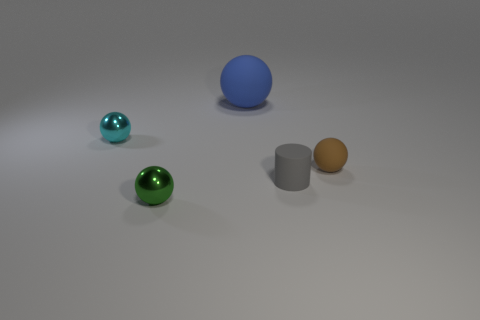Are there any other things that are the same shape as the tiny gray thing?
Make the answer very short. No. Are there any other things that have the same material as the green object?
Your answer should be very brief. Yes. What number of tiny brown matte things are the same shape as the blue thing?
Ensure brevity in your answer.  1. What is the shape of the tiny gray rubber thing in front of the small thing that is behind the brown object?
Provide a short and direct response. Cylinder. Does the sphere in front of the gray rubber thing have the same size as the tiny cyan sphere?
Provide a short and direct response. Yes. What is the size of the sphere that is to the right of the small green metallic object and in front of the cyan metal thing?
Offer a very short reply. Small. How many gray cylinders are the same size as the cyan sphere?
Your response must be concise. 1. There is a small sphere that is right of the tiny gray matte object; what number of cyan metallic spheres are in front of it?
Provide a short and direct response. 0. There is a rubber sphere on the right side of the gray rubber object; is it the same color as the cylinder?
Your answer should be compact. No. There is a metallic sphere that is behind the metallic ball that is in front of the cyan metal thing; is there a matte cylinder that is on the right side of it?
Your answer should be compact. Yes. 